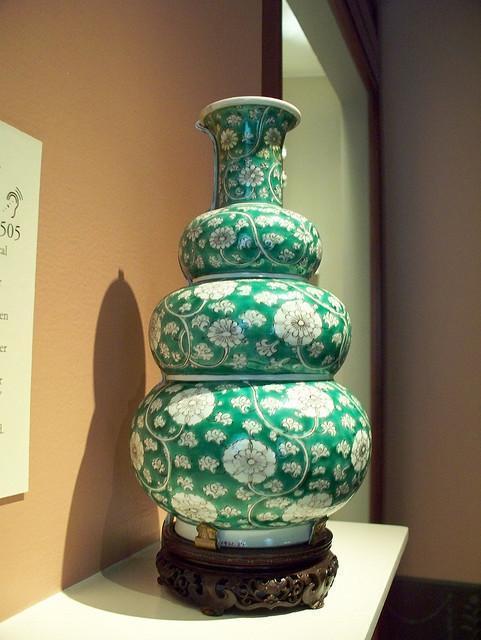How many vases are in the picture?
Give a very brief answer. 1. 